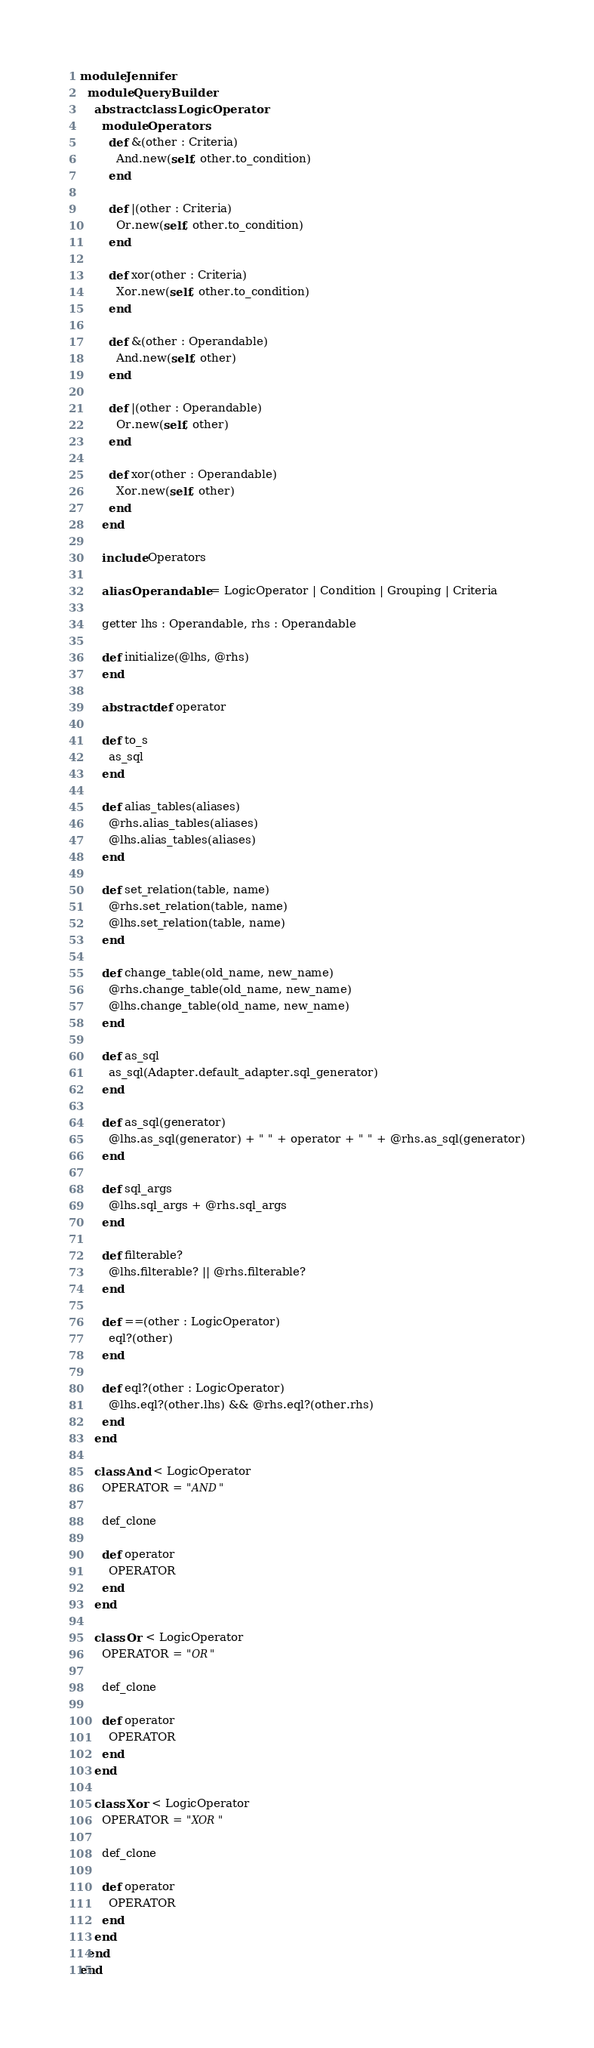<code> <loc_0><loc_0><loc_500><loc_500><_Crystal_>module Jennifer
  module QueryBuilder
    abstract class LogicOperator
      module Operators
        def &(other : Criteria)
          And.new(self, other.to_condition)
        end

        def |(other : Criteria)
          Or.new(self, other.to_condition)
        end

        def xor(other : Criteria)
          Xor.new(self, other.to_condition)
        end

        def &(other : Operandable)
          And.new(self, other)
        end

        def |(other : Operandable)
          Or.new(self, other)
        end

        def xor(other : Operandable)
          Xor.new(self, other)
        end
      end

      include Operators

      alias Operandable = LogicOperator | Condition | Grouping | Criteria

      getter lhs : Operandable, rhs : Operandable

      def initialize(@lhs, @rhs)
      end

      abstract def operator

      def to_s
        as_sql
      end

      def alias_tables(aliases)
        @rhs.alias_tables(aliases)
        @lhs.alias_tables(aliases)
      end

      def set_relation(table, name)
        @rhs.set_relation(table, name)
        @lhs.set_relation(table, name)
      end

      def change_table(old_name, new_name)
        @rhs.change_table(old_name, new_name)
        @lhs.change_table(old_name, new_name)
      end

      def as_sql
        as_sql(Adapter.default_adapter.sql_generator)
      end

      def as_sql(generator)
        @lhs.as_sql(generator) + " " + operator + " " + @rhs.as_sql(generator)
      end

      def sql_args
        @lhs.sql_args + @rhs.sql_args
      end

      def filterable?
        @lhs.filterable? || @rhs.filterable?
      end

      def ==(other : LogicOperator)
        eql?(other)
      end

      def eql?(other : LogicOperator)
        @lhs.eql?(other.lhs) && @rhs.eql?(other.rhs)
      end
    end

    class And < LogicOperator
      OPERATOR = "AND"

      def_clone

      def operator
        OPERATOR
      end
    end

    class Or < LogicOperator
      OPERATOR = "OR"

      def_clone

      def operator
        OPERATOR
      end
    end

    class Xor < LogicOperator
      OPERATOR = "XOR"

      def_clone

      def operator
        OPERATOR
      end
    end
  end
end
</code> 